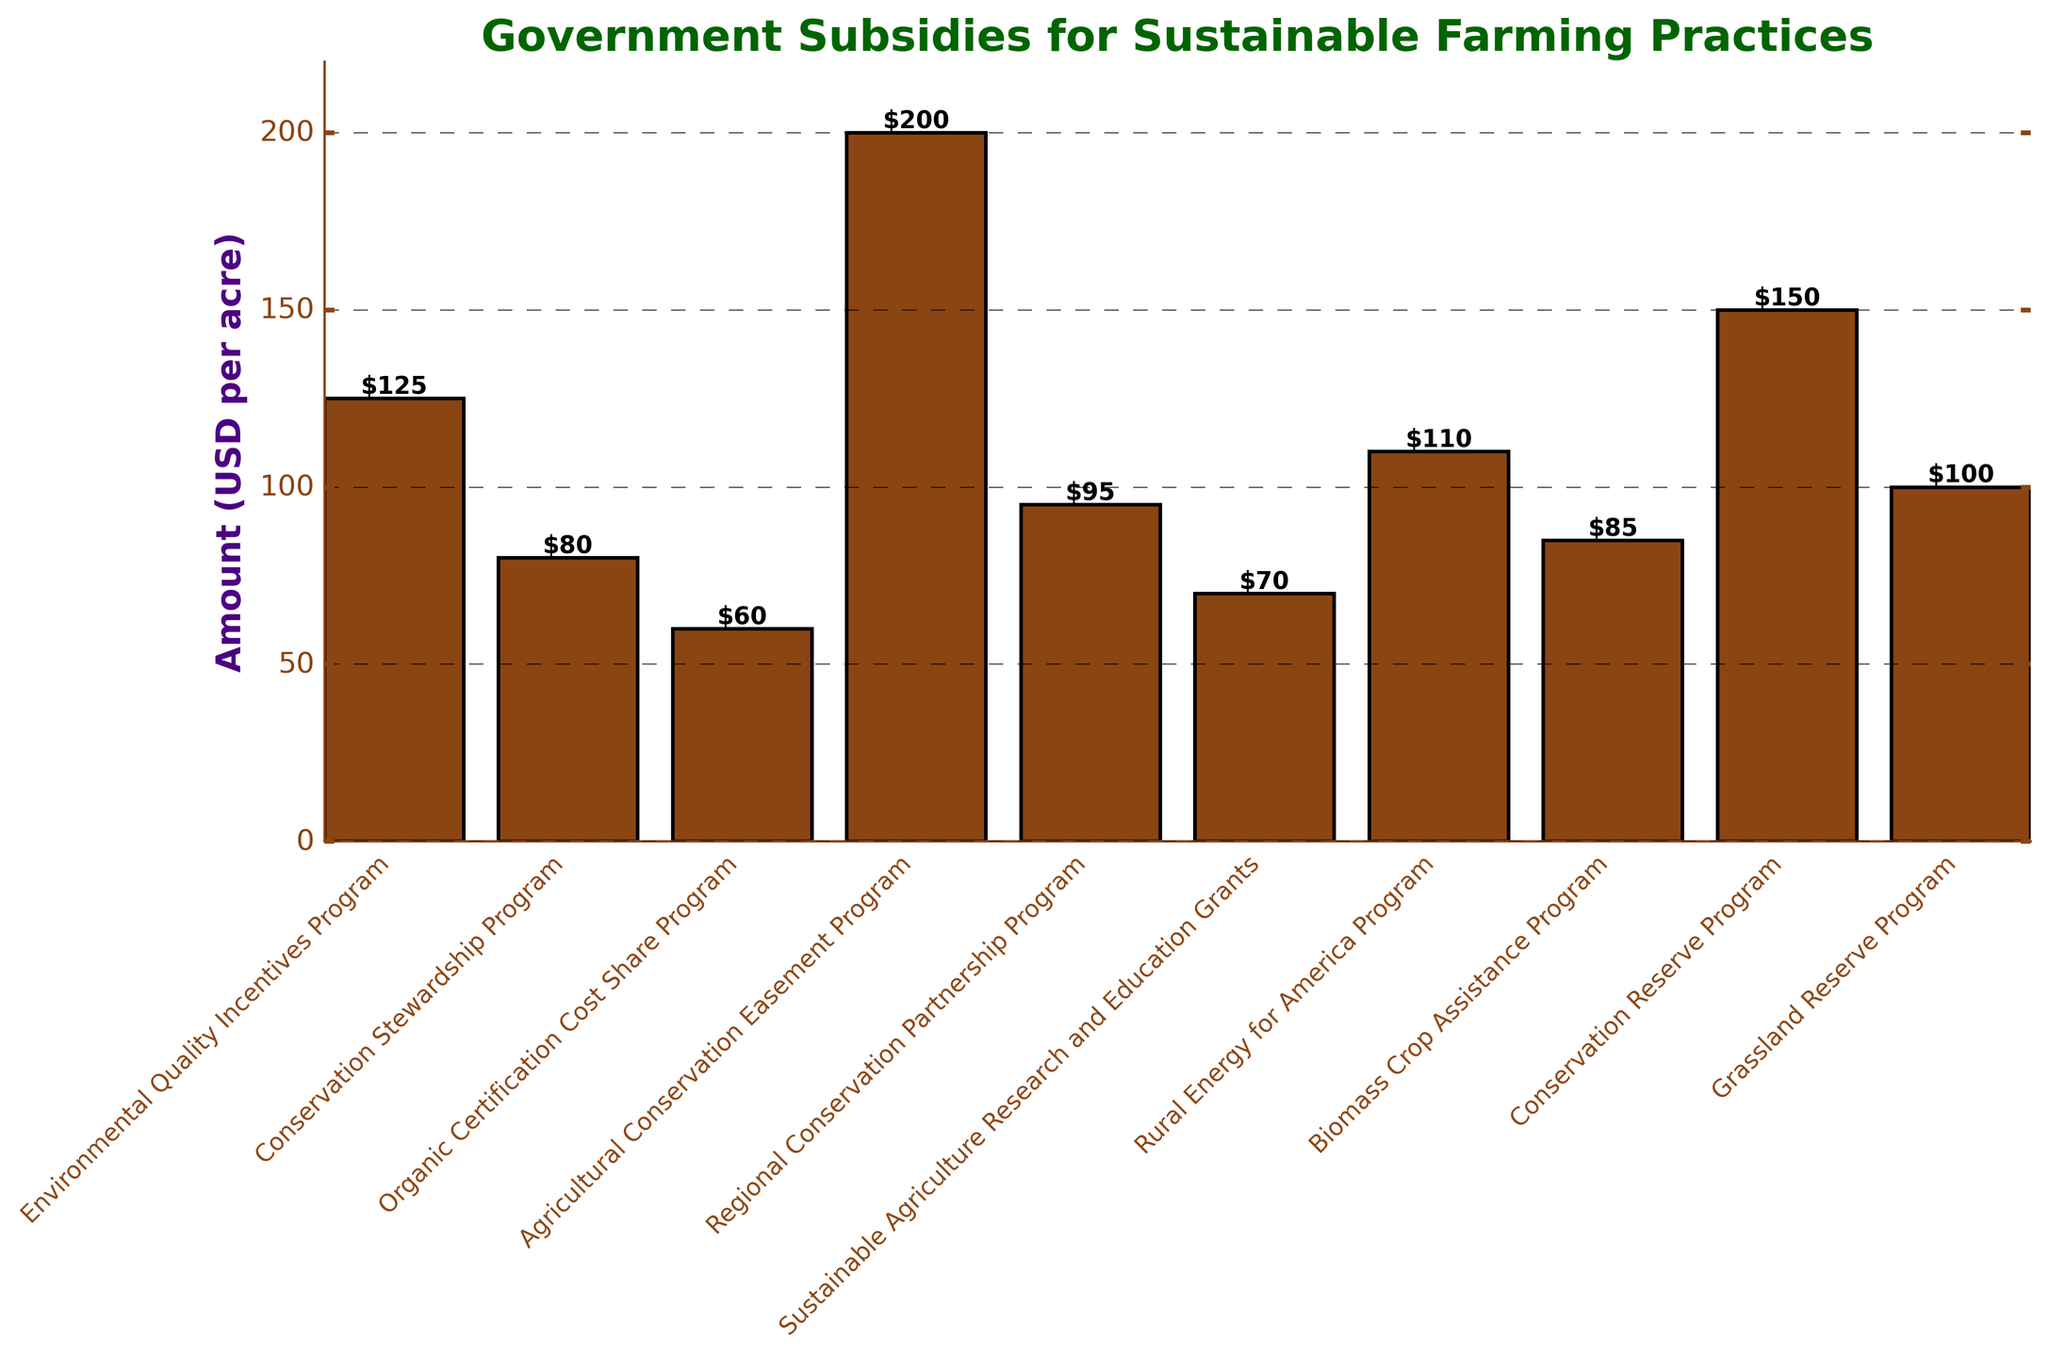What's the highest subsidy program amount? The highest bar represents the maximum amount. Observing the heights of all bars, the 'Agricultural Conservation Easement Program' has the highest bar.
Answer: Agricultural Conservation Easement Program Which subsidy program has the lowest amount? The shortest bar represents the minimum amount. Observing the heights of all bars, the 'Organic Certification Cost Share Program' has the shortest bar.
Answer: Organic Certification Cost Share Program What is the total subsidy amount for Conservation Stewardship Program and Biomass Crop Assistance Program? Identify the amounts for both programs from the bars. Conservation Stewardship Program is $80 and Biomass Crop Assistance Program is $85. Adding them gives $80 + $85 = $165.
Answer: $165 What is the difference in subsidy amounts between the Conservation Reserve Program and the Grassland Reserve Program? Identify the amounts for both programs from the bars. Conservation Reserve Program is $150 and Grassland Reserve Program is $100. Subtracting gives $150 - $100 = $50.
Answer: $50 Which two programs have subsidy amounts closest in value? Compare the heights of the bars to find the two closest. The Biomass Crop Assistance Program ($85) and the Grassland Reserve Program ($100) are closest with a difference of $15.
Answer: Biomass Crop Assistance Program and Grassland Reserve Program What is the average subsidy amount across all programs? Sum all subsidy amounts from each bar: 125 + 80 + 60 + 200 + 95 + 70 + 110 + 85 + 150 + 100 = 1075. Then divide by the number of programs (10): 1075 / 10 = 107.5.
Answer: $107.5 Which subsidy program is represented by the second tallest bar? Observing the heights of the bars, the second tallest one is for the Conservation Reserve Program.
Answer: Conservation Reserve Program How much more is the subsidy for the Rural Energy for America Program compared to the Organic Certification Cost Share Program? Identify the amounts for both programs from the bars. Rural Energy for America Program is $110, and Organic Certification Cost Share Program is $60. Subtracting gives $110 - $60 = $50.
Answer: $50 What is the combined amount of the top three highest subsidy programs? The top three programs based on bar heights are Agricultural Conservation Easement Program ($200), Conservation Reserve Program ($150), and Environmental Quality Incentives Program ($125). Adding them gives $200 + $150 + $125 = $475.
Answer: $475 